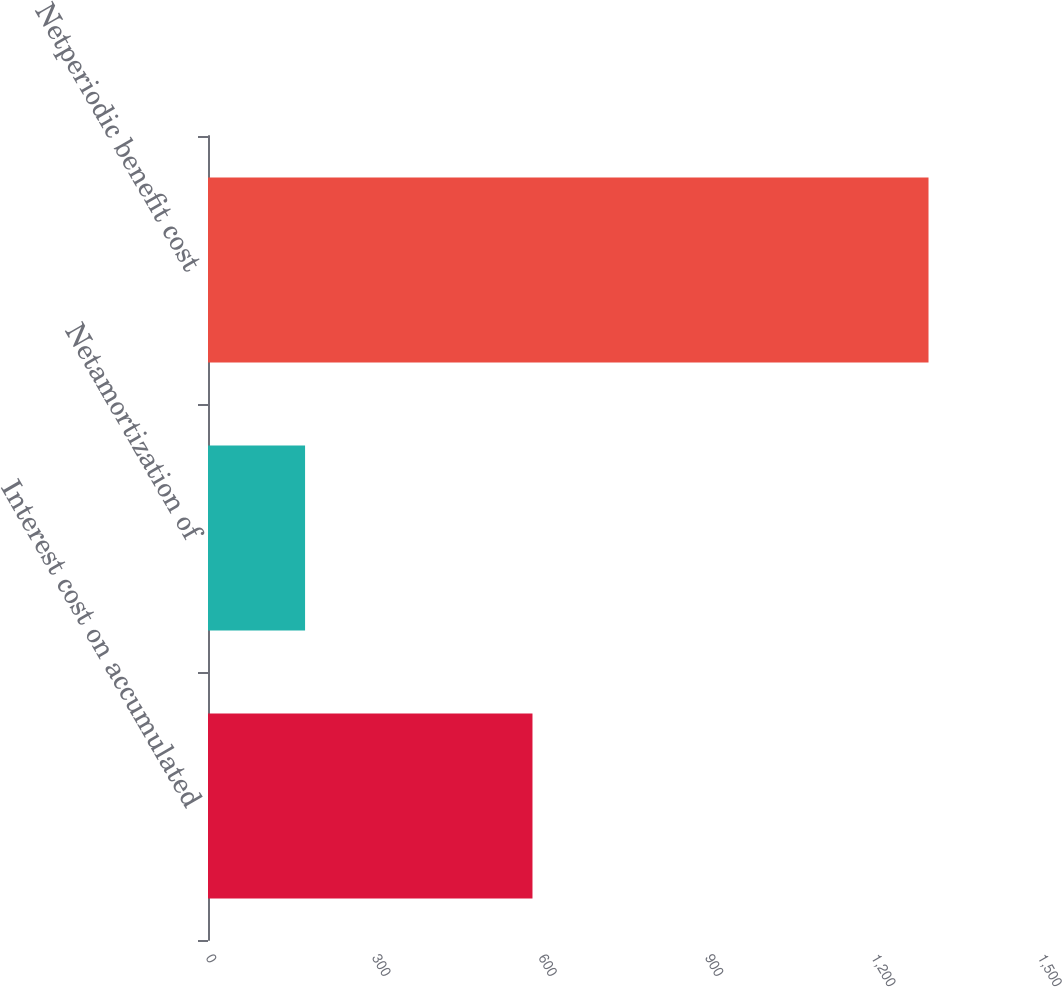<chart> <loc_0><loc_0><loc_500><loc_500><bar_chart><fcel>Interest cost on accumulated<fcel>Netamortization of<fcel>Netperiodic benefit cost<nl><fcel>585<fcel>175<fcel>1299<nl></chart> 